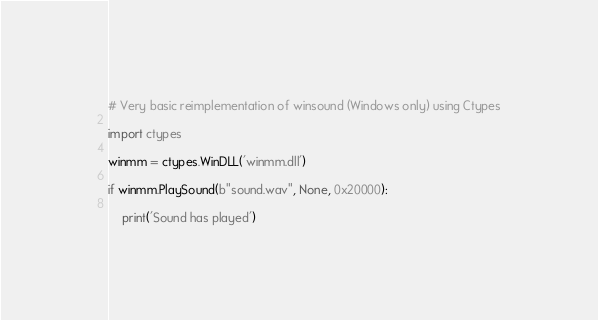<code> <loc_0><loc_0><loc_500><loc_500><_Python_># Very basic reimplementation of winsound (Windows only) using Ctypes

import ctypes

winmm = ctypes.WinDLL('winmm.dll')

if winmm.PlaySound(b"sound.wav", None, 0x20000):

    print('Sound has played')
</code> 